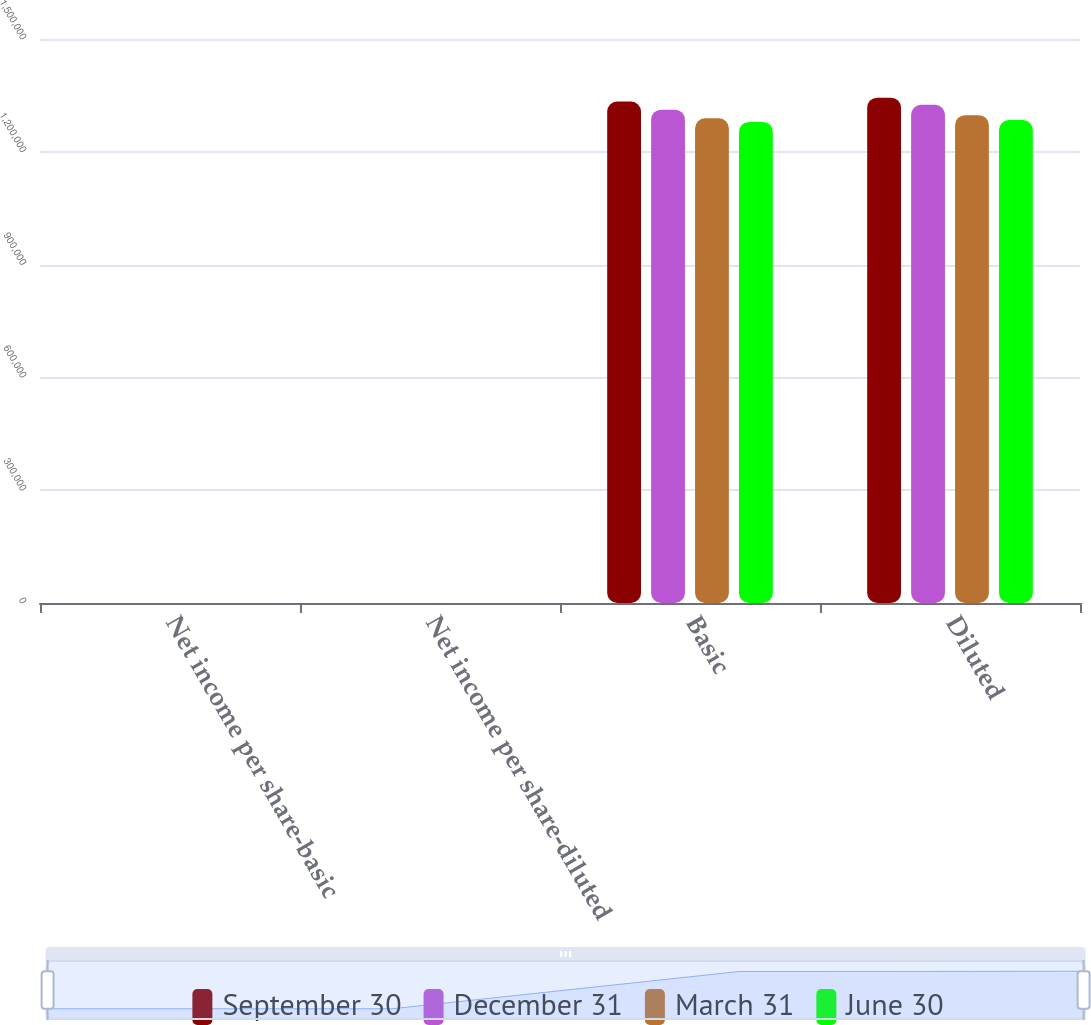Convert chart to OTSL. <chart><loc_0><loc_0><loc_500><loc_500><stacked_bar_chart><ecel><fcel>Net income per share-basic<fcel>Net income per share-diluted<fcel>Basic<fcel>Diluted<nl><fcel>September 30<fcel>0.34<fcel>0.34<fcel>1.33379e+06<fcel>1.34399e+06<nl><fcel>December 31<fcel>0.35<fcel>0.35<fcel>1.31201e+06<fcel>1.32514e+06<nl><fcel>March 31<fcel>0.38<fcel>0.38<fcel>1.28894e+06<fcel>1.29748e+06<nl><fcel>June 30<fcel>0.29<fcel>0.29<fcel>1.27954e+06<fcel>1.28428e+06<nl></chart> 